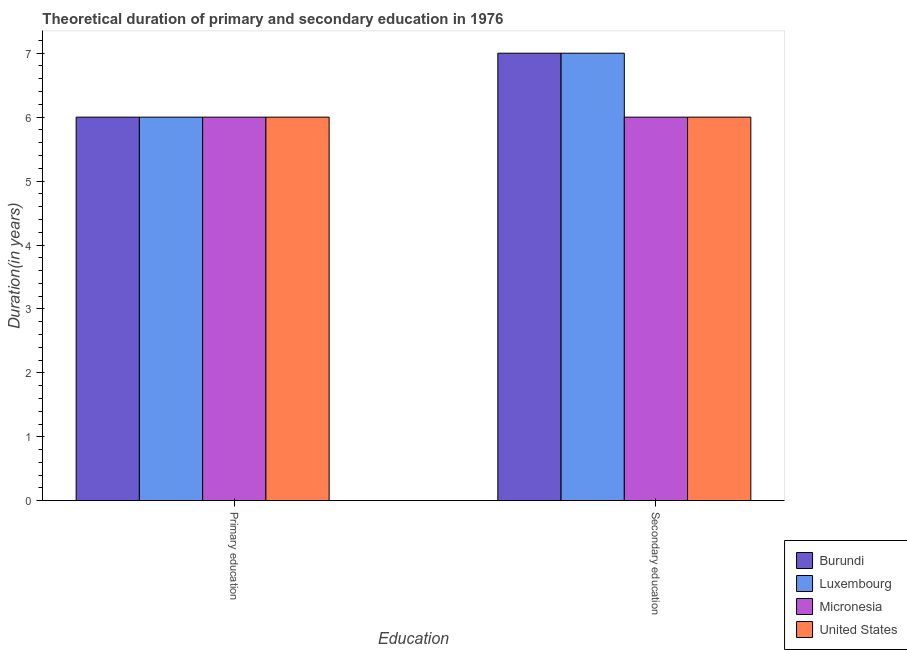Are the number of bars per tick equal to the number of legend labels?
Your answer should be compact. Yes. Are the number of bars on each tick of the X-axis equal?
Your response must be concise. Yes. How many bars are there on the 1st tick from the left?
Your response must be concise. 4. What is the label of the 1st group of bars from the left?
Keep it short and to the point. Primary education. What is the duration of primary education in Micronesia?
Provide a succinct answer. 6. Across all countries, what is the maximum duration of secondary education?
Make the answer very short. 7. In which country was the duration of secondary education maximum?
Keep it short and to the point. Burundi. In which country was the duration of secondary education minimum?
Offer a terse response. Micronesia. What is the total duration of secondary education in the graph?
Keep it short and to the point. 26. What is the difference between the duration of secondary education in Burundi and the duration of primary education in Luxembourg?
Keep it short and to the point. 1. What is the difference between the duration of secondary education and duration of primary education in Burundi?
Your response must be concise. 1. In how many countries, is the duration of primary education greater than the average duration of primary education taken over all countries?
Your response must be concise. 0. What does the 3rd bar from the left in Secondary education represents?
Offer a terse response. Micronesia. How many bars are there?
Provide a short and direct response. 8. Are all the bars in the graph horizontal?
Provide a succinct answer. No. What is the difference between two consecutive major ticks on the Y-axis?
Provide a short and direct response. 1. Are the values on the major ticks of Y-axis written in scientific E-notation?
Keep it short and to the point. No. Does the graph contain any zero values?
Make the answer very short. No. Does the graph contain grids?
Ensure brevity in your answer.  No. What is the title of the graph?
Make the answer very short. Theoretical duration of primary and secondary education in 1976. Does "United States" appear as one of the legend labels in the graph?
Your answer should be very brief. Yes. What is the label or title of the X-axis?
Offer a terse response. Education. What is the label or title of the Y-axis?
Provide a succinct answer. Duration(in years). What is the Duration(in years) of Micronesia in Primary education?
Offer a very short reply. 6. What is the Duration(in years) in Burundi in Secondary education?
Your response must be concise. 7. What is the Duration(in years) in Micronesia in Secondary education?
Make the answer very short. 6. What is the Duration(in years) in United States in Secondary education?
Your response must be concise. 6. Across all Education, what is the maximum Duration(in years) of Burundi?
Provide a succinct answer. 7. Across all Education, what is the maximum Duration(in years) in Micronesia?
Offer a terse response. 6. Across all Education, what is the maximum Duration(in years) of United States?
Offer a very short reply. 6. Across all Education, what is the minimum Duration(in years) in Burundi?
Give a very brief answer. 6. Across all Education, what is the minimum Duration(in years) in Luxembourg?
Your response must be concise. 6. What is the total Duration(in years) in Burundi in the graph?
Your answer should be compact. 13. What is the total Duration(in years) in Luxembourg in the graph?
Keep it short and to the point. 13. What is the difference between the Duration(in years) in Burundi in Primary education and that in Secondary education?
Your answer should be very brief. -1. What is the difference between the Duration(in years) in Luxembourg in Primary education and that in Secondary education?
Your answer should be compact. -1. What is the difference between the Duration(in years) of United States in Primary education and that in Secondary education?
Your response must be concise. 0. What is the difference between the Duration(in years) of Burundi in Primary education and the Duration(in years) of Micronesia in Secondary education?
Make the answer very short. 0. What is the difference between the Duration(in years) of Luxembourg in Primary education and the Duration(in years) of Micronesia in Secondary education?
Provide a succinct answer. 0. What is the difference between the Duration(in years) of Luxembourg in Primary education and the Duration(in years) of United States in Secondary education?
Make the answer very short. 0. What is the average Duration(in years) in Burundi per Education?
Offer a very short reply. 6.5. What is the average Duration(in years) of Luxembourg per Education?
Offer a terse response. 6.5. What is the average Duration(in years) of United States per Education?
Keep it short and to the point. 6. What is the difference between the Duration(in years) of Luxembourg and Duration(in years) of Micronesia in Primary education?
Your answer should be compact. 0. What is the difference between the Duration(in years) of Luxembourg and Duration(in years) of United States in Primary education?
Provide a succinct answer. 0. What is the difference between the Duration(in years) in Burundi and Duration(in years) in Luxembourg in Secondary education?
Make the answer very short. 0. What is the difference between the Duration(in years) in Burundi and Duration(in years) in Micronesia in Secondary education?
Provide a short and direct response. 1. What is the difference between the Duration(in years) of Luxembourg and Duration(in years) of Micronesia in Secondary education?
Keep it short and to the point. 1. What is the ratio of the Duration(in years) of Burundi in Primary education to that in Secondary education?
Your response must be concise. 0.86. What is the ratio of the Duration(in years) of Luxembourg in Primary education to that in Secondary education?
Ensure brevity in your answer.  0.86. What is the ratio of the Duration(in years) in Micronesia in Primary education to that in Secondary education?
Ensure brevity in your answer.  1. What is the difference between the highest and the second highest Duration(in years) in Luxembourg?
Offer a very short reply. 1. What is the difference between the highest and the second highest Duration(in years) of Micronesia?
Offer a terse response. 0. What is the difference between the highest and the second highest Duration(in years) in United States?
Offer a very short reply. 0. What is the difference between the highest and the lowest Duration(in years) in Micronesia?
Provide a succinct answer. 0. 